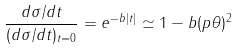Convert formula to latex. <formula><loc_0><loc_0><loc_500><loc_500>\frac { d \sigma / d t } { ( d \sigma / d t ) _ { t = 0 } } = e ^ { - b | t | } \simeq 1 - b ( p \theta ) ^ { 2 }</formula> 